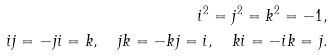<formula> <loc_0><loc_0><loc_500><loc_500>i ^ { 2 } = j ^ { 2 } = k ^ { 2 } = - 1 , \\ i j = - j i = k , \quad j k = - k j = i , \quad k i = - i k = j .</formula> 